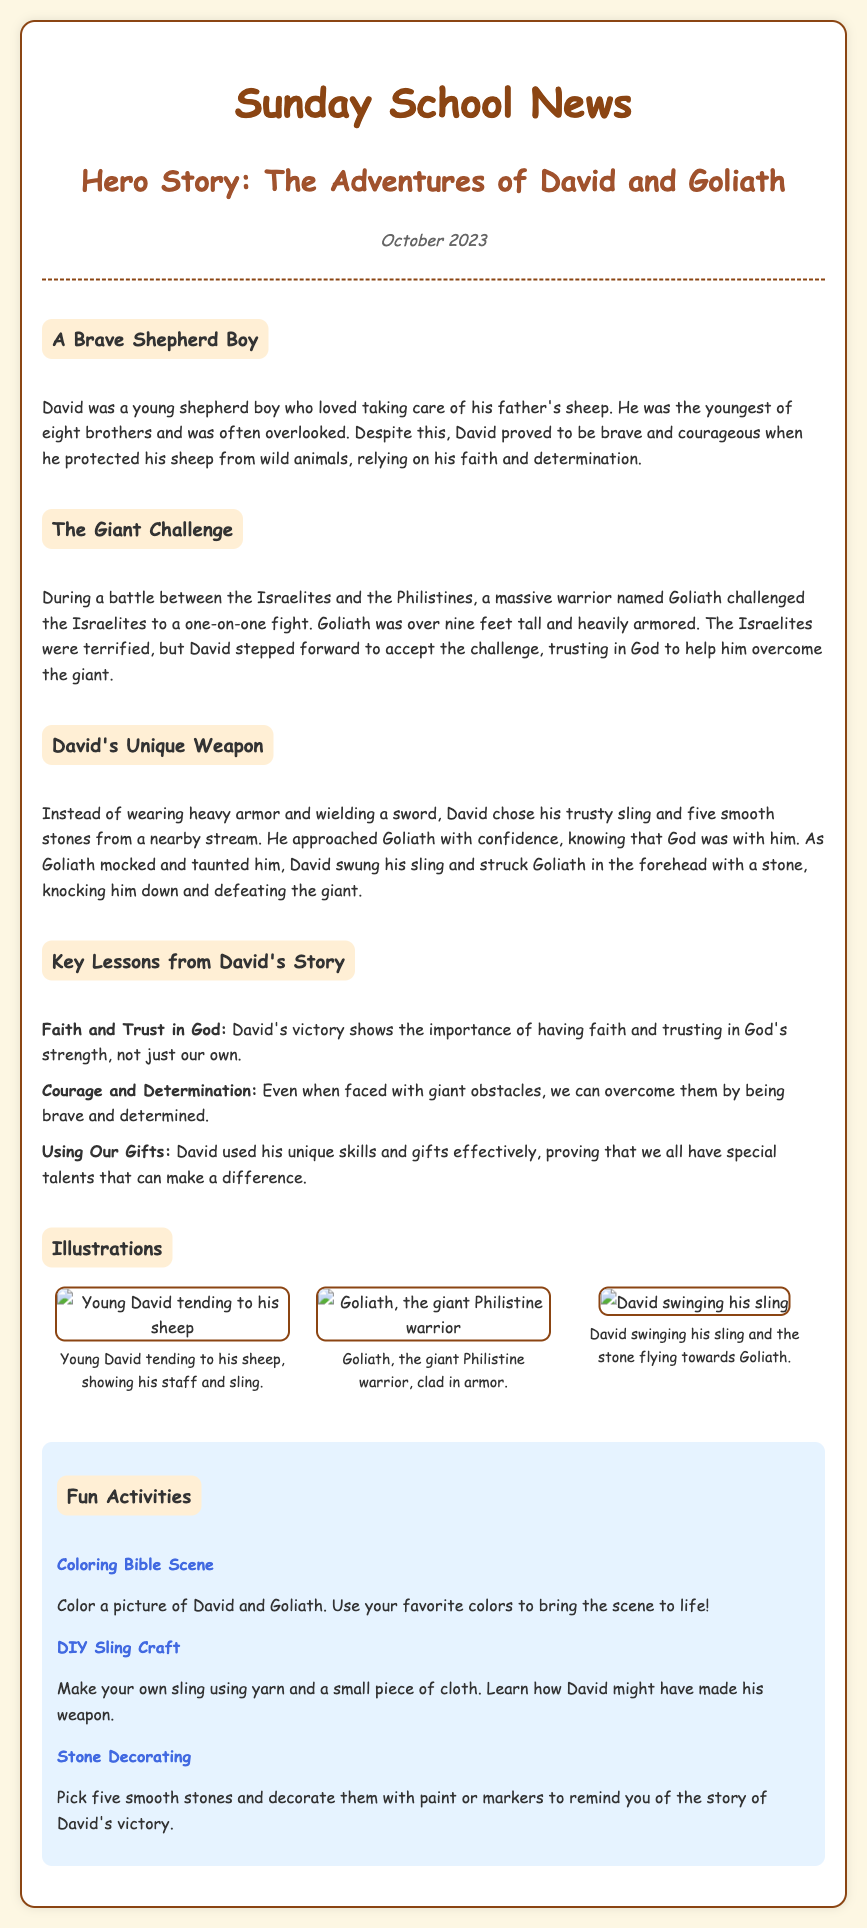What was David's occupation? David was a young shepherd boy who loved taking care of his father's sheep.
Answer: Shepherd How tall was Goliath? Goliath was described as being over nine feet tall.
Answer: Nine feet What weapon did David choose? David chose his trusty sling and five smooth stones from a nearby stream.
Answer: Sling What is one key lesson from David's story? One of the key lessons is the importance of having faith and trusting in God's strength.
Answer: Faith and Trust in God What activity involves coloring? The activity that involves coloring is to color a picture of David and Goliath.
Answer: Coloring Bible Scene What is the publishing month of the document? The document is dated October 2023.
Answer: October Who challenged the Israelites to a fight? A massive warrior named Goliath challenged the Israelites.
Answer: Goliath What unique skill did David use to defeat Goliath? David used his unique skill of using a sling to defeat Goliath.
Answer: Sling What shape were the stones David picked? David picked five smooth stones from a nearby stream.
Answer: Smooth 